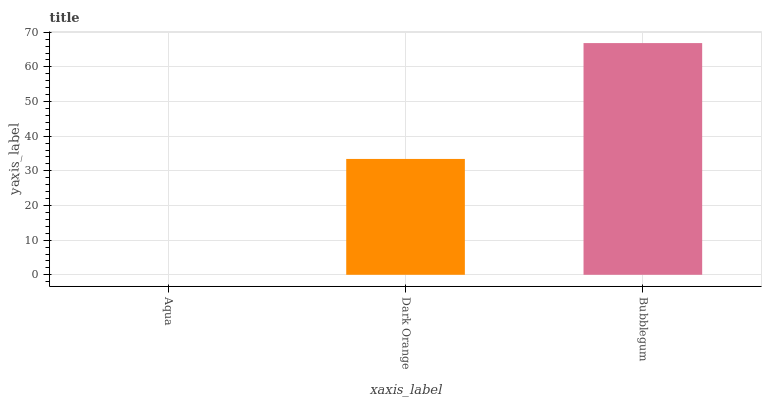Is Aqua the minimum?
Answer yes or no. Yes. Is Bubblegum the maximum?
Answer yes or no. Yes. Is Dark Orange the minimum?
Answer yes or no. No. Is Dark Orange the maximum?
Answer yes or no. No. Is Dark Orange greater than Aqua?
Answer yes or no. Yes. Is Aqua less than Dark Orange?
Answer yes or no. Yes. Is Aqua greater than Dark Orange?
Answer yes or no. No. Is Dark Orange less than Aqua?
Answer yes or no. No. Is Dark Orange the high median?
Answer yes or no. Yes. Is Dark Orange the low median?
Answer yes or no. Yes. Is Bubblegum the high median?
Answer yes or no. No. Is Aqua the low median?
Answer yes or no. No. 